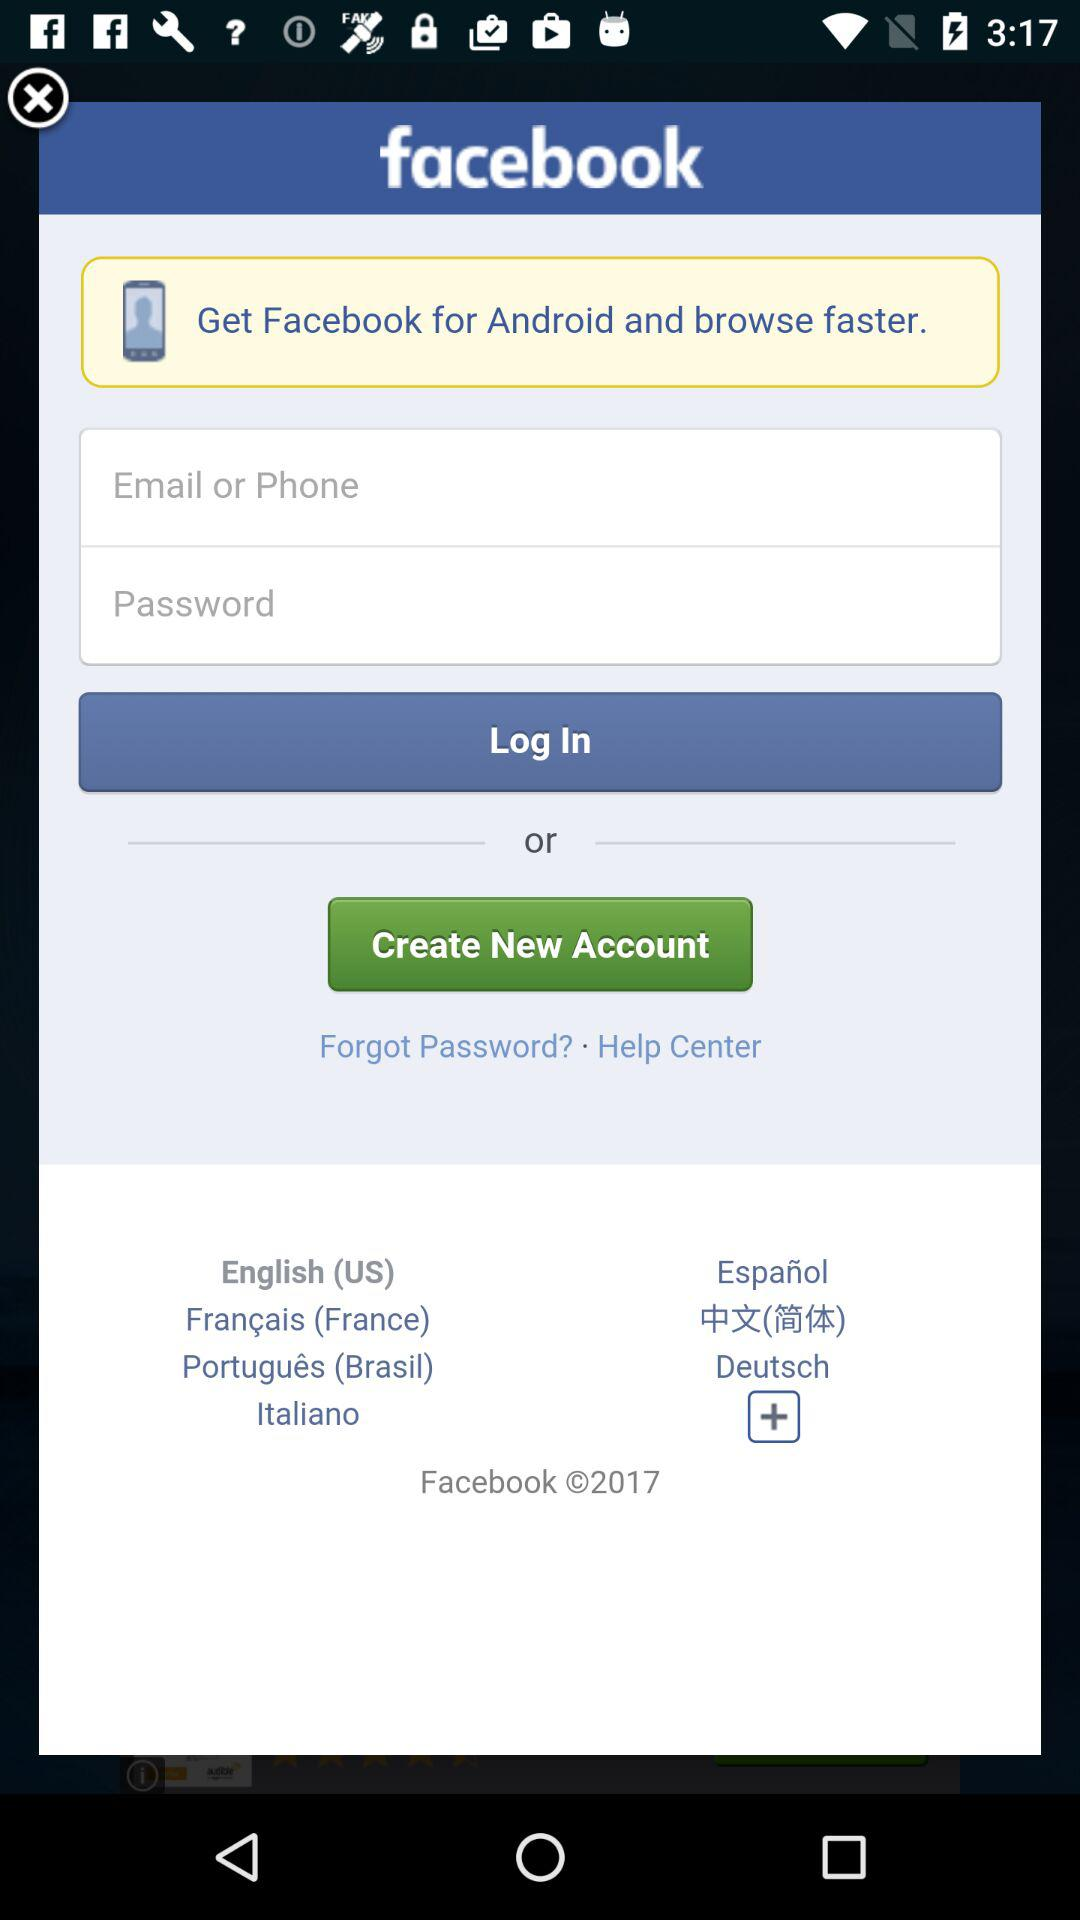How many text input fields are there for logging in to Facebook?
Answer the question using a single word or phrase. 2 